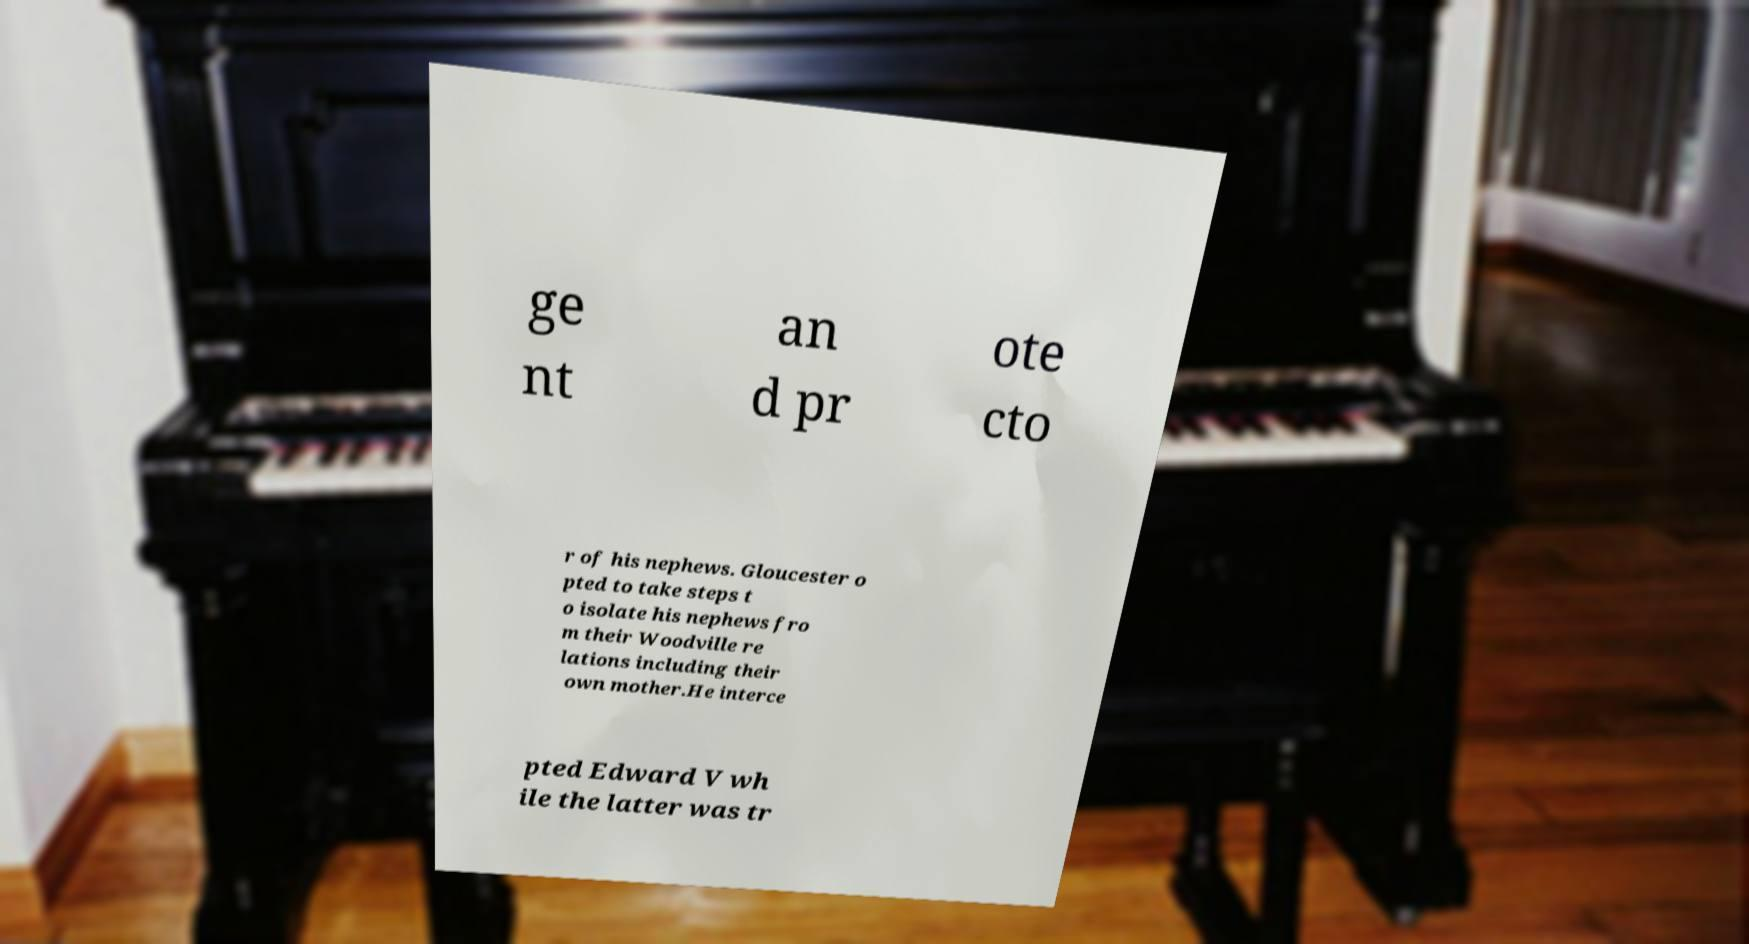Can you read and provide the text displayed in the image?This photo seems to have some interesting text. Can you extract and type it out for me? ge nt an d pr ote cto r of his nephews. Gloucester o pted to take steps t o isolate his nephews fro m their Woodville re lations including their own mother.He interce pted Edward V wh ile the latter was tr 